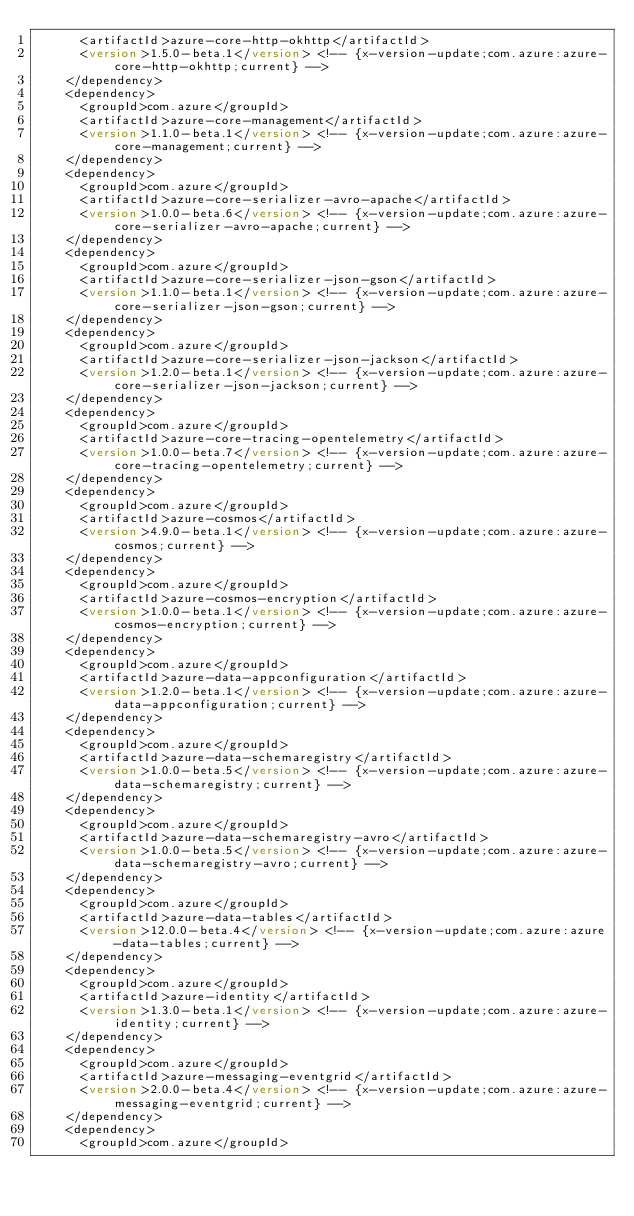Convert code to text. <code><loc_0><loc_0><loc_500><loc_500><_XML_>      <artifactId>azure-core-http-okhttp</artifactId>
      <version>1.5.0-beta.1</version> <!-- {x-version-update;com.azure:azure-core-http-okhttp;current} -->
    </dependency>
    <dependency>
      <groupId>com.azure</groupId>
      <artifactId>azure-core-management</artifactId>
      <version>1.1.0-beta.1</version> <!-- {x-version-update;com.azure:azure-core-management;current} -->
    </dependency>
    <dependency>
      <groupId>com.azure</groupId>
      <artifactId>azure-core-serializer-avro-apache</artifactId>
      <version>1.0.0-beta.6</version> <!-- {x-version-update;com.azure:azure-core-serializer-avro-apache;current} -->
    </dependency>
    <dependency>
      <groupId>com.azure</groupId>
      <artifactId>azure-core-serializer-json-gson</artifactId>
      <version>1.1.0-beta.1</version> <!-- {x-version-update;com.azure:azure-core-serializer-json-gson;current} -->
    </dependency>
    <dependency>
      <groupId>com.azure</groupId>
      <artifactId>azure-core-serializer-json-jackson</artifactId>
      <version>1.2.0-beta.1</version> <!-- {x-version-update;com.azure:azure-core-serializer-json-jackson;current} -->
    </dependency>
    <dependency>
      <groupId>com.azure</groupId>
      <artifactId>azure-core-tracing-opentelemetry</artifactId>
      <version>1.0.0-beta.7</version> <!-- {x-version-update;com.azure:azure-core-tracing-opentelemetry;current} -->
    </dependency>
    <dependency>
      <groupId>com.azure</groupId>
      <artifactId>azure-cosmos</artifactId>
      <version>4.9.0-beta.1</version> <!-- {x-version-update;com.azure:azure-cosmos;current} -->
    </dependency>
    <dependency>
      <groupId>com.azure</groupId>
      <artifactId>azure-cosmos-encryption</artifactId>
      <version>1.0.0-beta.1</version> <!-- {x-version-update;com.azure:azure-cosmos-encryption;current} -->
    </dependency>
    <dependency>
      <groupId>com.azure</groupId>
      <artifactId>azure-data-appconfiguration</artifactId>
      <version>1.2.0-beta.1</version> <!-- {x-version-update;com.azure:azure-data-appconfiguration;current} -->
    </dependency>
    <dependency>
      <groupId>com.azure</groupId>
      <artifactId>azure-data-schemaregistry</artifactId>
      <version>1.0.0-beta.5</version> <!-- {x-version-update;com.azure:azure-data-schemaregistry;current} -->
    </dependency>
    <dependency>
      <groupId>com.azure</groupId>
      <artifactId>azure-data-schemaregistry-avro</artifactId>
      <version>1.0.0-beta.5</version> <!-- {x-version-update;com.azure:azure-data-schemaregistry-avro;current} -->
    </dependency>
    <dependency>
      <groupId>com.azure</groupId>
      <artifactId>azure-data-tables</artifactId>
      <version>12.0.0-beta.4</version> <!-- {x-version-update;com.azure:azure-data-tables;current} -->
    </dependency>
    <dependency>
      <groupId>com.azure</groupId>
      <artifactId>azure-identity</artifactId>
      <version>1.3.0-beta.1</version> <!-- {x-version-update;com.azure:azure-identity;current} -->
    </dependency>
    <dependency>
      <groupId>com.azure</groupId>
      <artifactId>azure-messaging-eventgrid</artifactId>
      <version>2.0.0-beta.4</version> <!-- {x-version-update;com.azure:azure-messaging-eventgrid;current} -->
    </dependency>
    <dependency>
      <groupId>com.azure</groupId></code> 